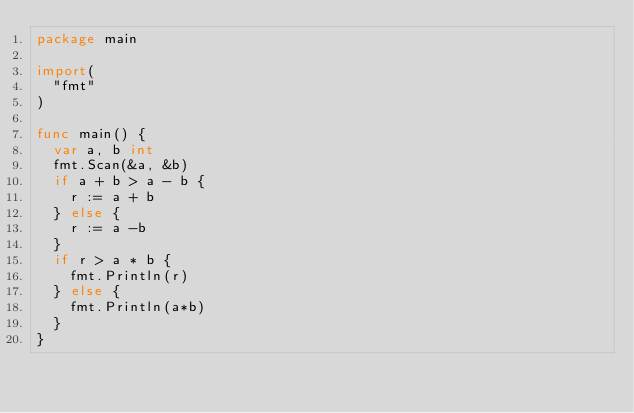<code> <loc_0><loc_0><loc_500><loc_500><_Go_>package main

import(
  "fmt"
)

func main() {
  var a, b int
  fmt.Scan(&a, &b)
  if a + b > a - b {
    r := a + b
  } else {
    r := a -b 
  }
  if r > a * b {
    fmt.Println(r)
  } else {
    fmt.Println(a*b)
  }
}</code> 